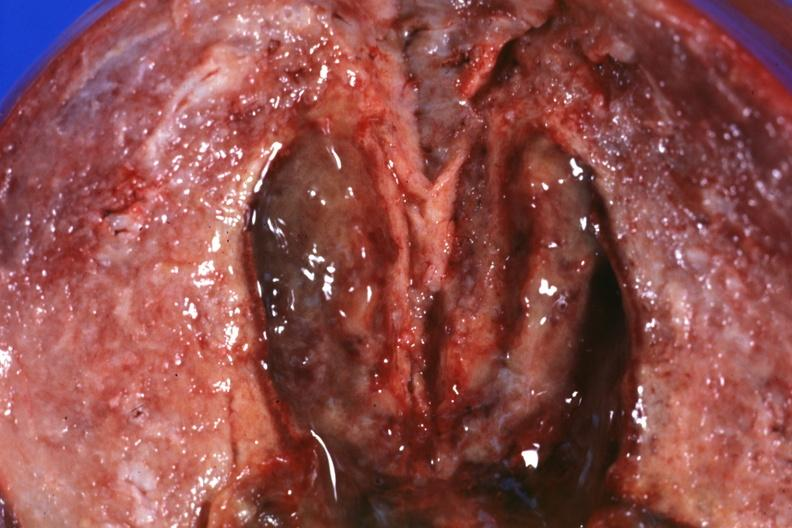s female reproductive present?
Answer the question using a single word or phrase. Yes 